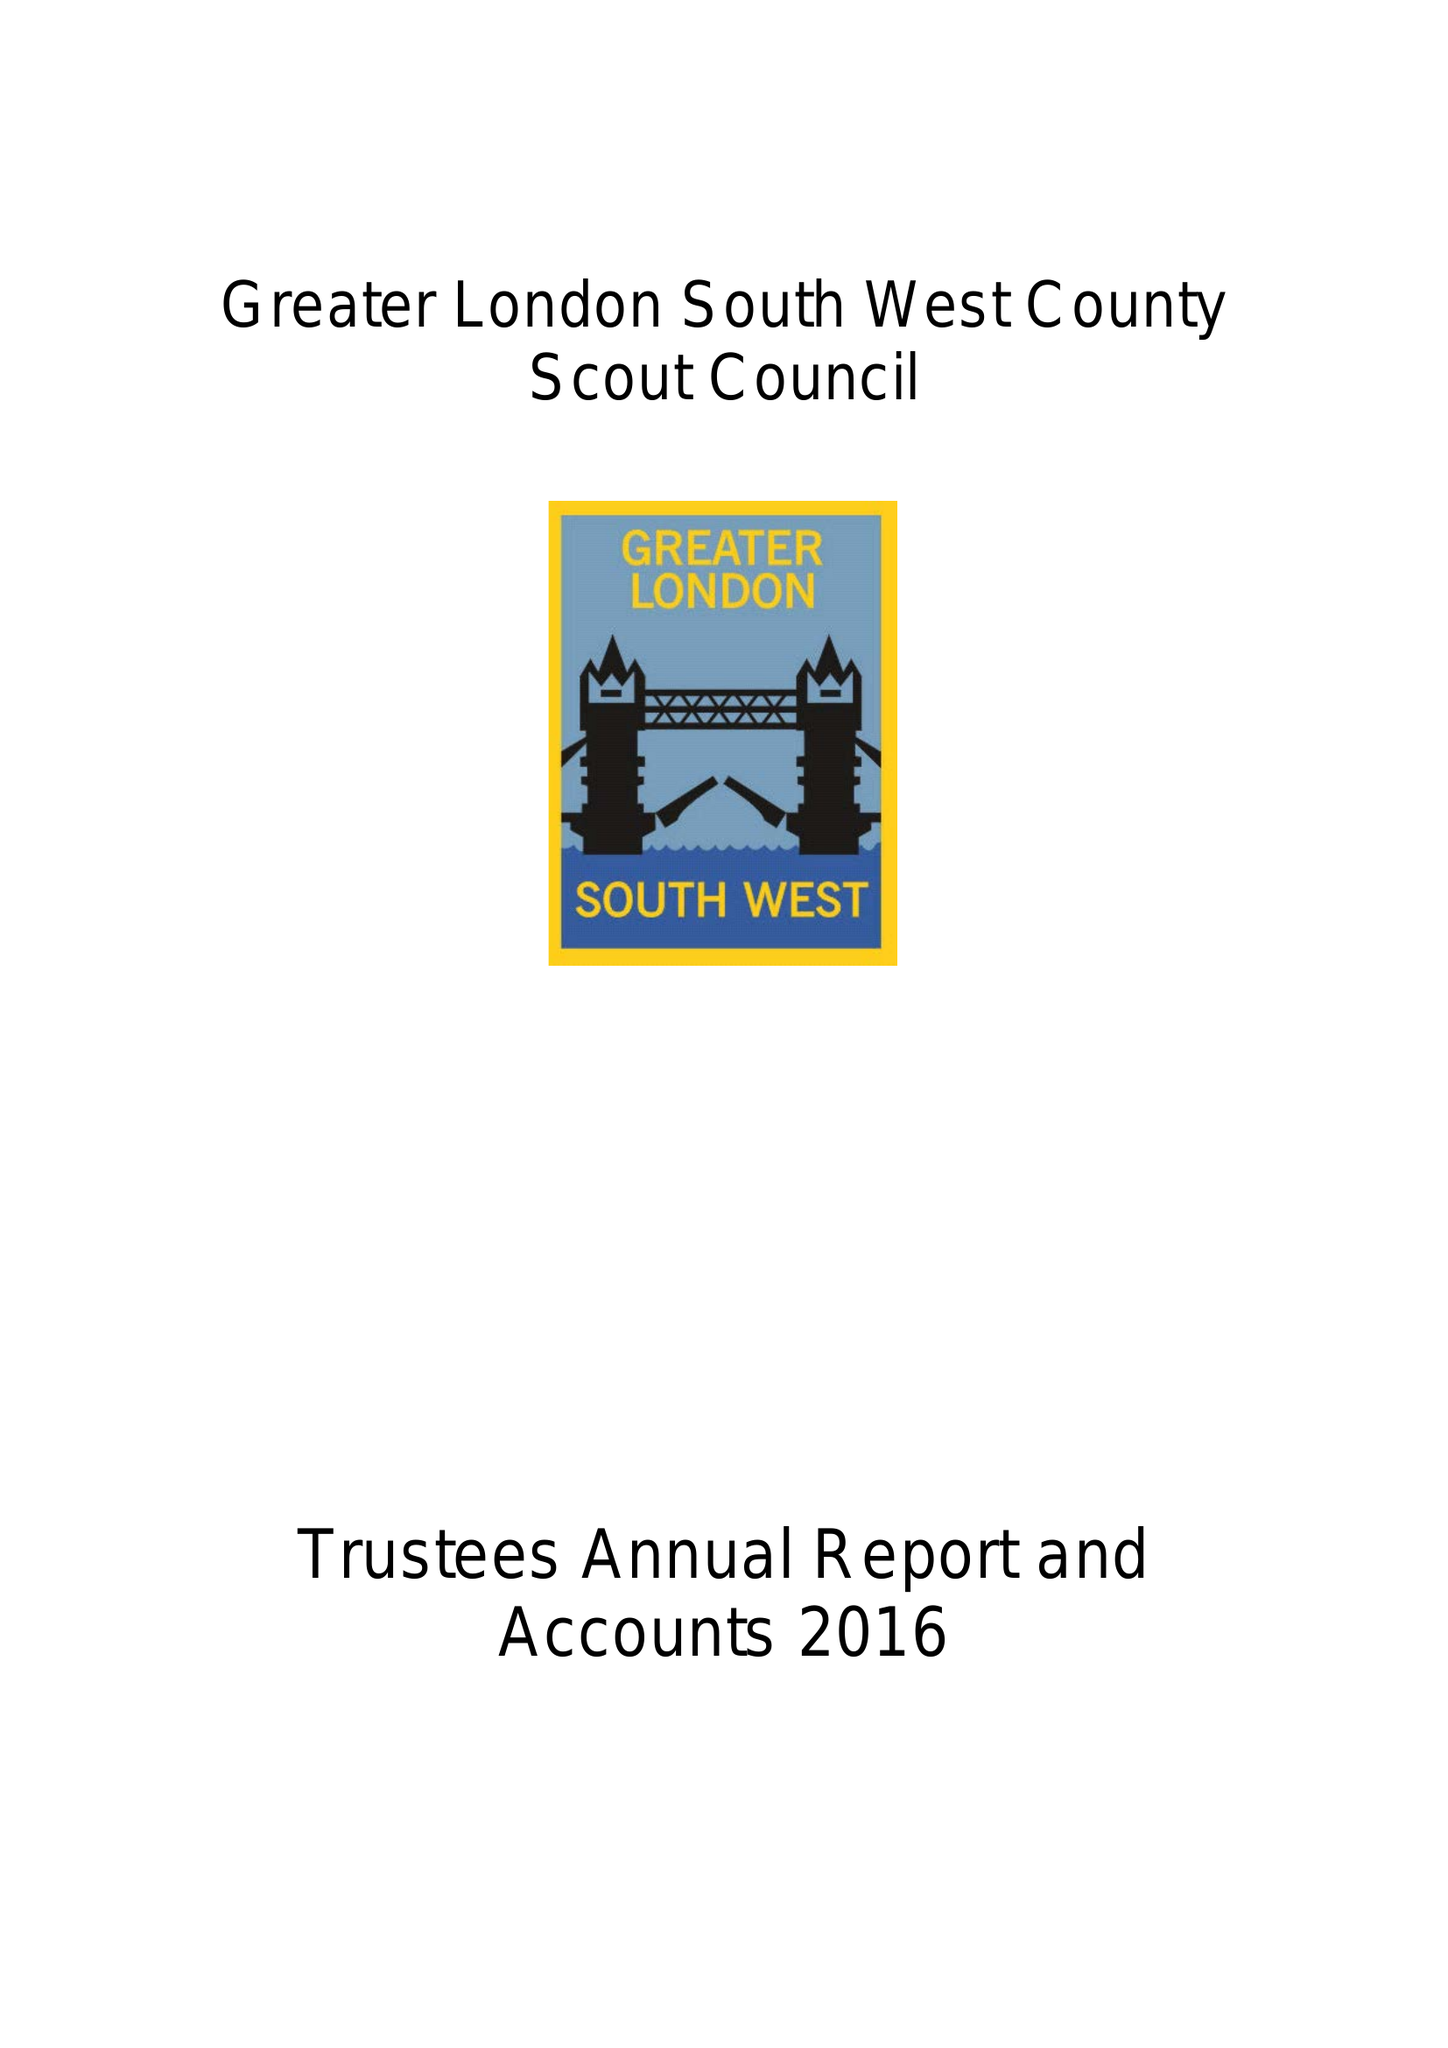What is the value for the charity_number?
Answer the question using a single word or phrase. 303884 